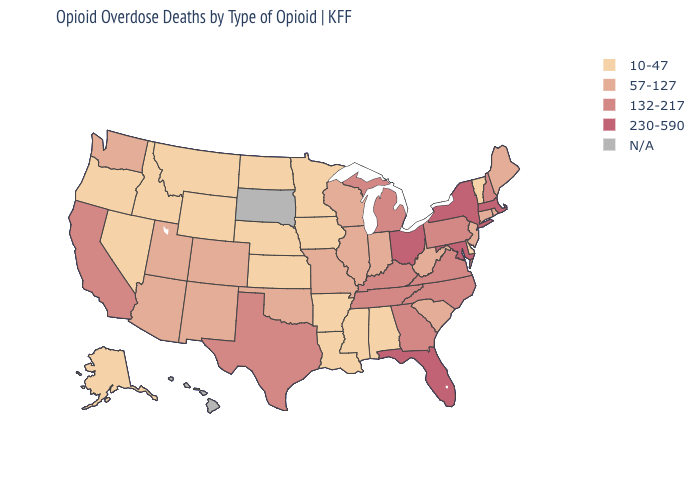Is the legend a continuous bar?
Quick response, please. No. Does Iowa have the lowest value in the USA?
Write a very short answer. Yes. What is the lowest value in the USA?
Give a very brief answer. 10-47. What is the value of Maryland?
Be succinct. 230-590. Name the states that have a value in the range 57-127?
Quick response, please. Arizona, Colorado, Connecticut, Illinois, Indiana, Maine, Missouri, New Jersey, New Mexico, Oklahoma, Rhode Island, South Carolina, Utah, Washington, West Virginia, Wisconsin. What is the value of New Jersey?
Answer briefly. 57-127. What is the value of Oregon?
Keep it brief. 10-47. What is the value of Virginia?
Write a very short answer. 132-217. Which states have the lowest value in the Northeast?
Answer briefly. Vermont. Name the states that have a value in the range 57-127?
Keep it brief. Arizona, Colorado, Connecticut, Illinois, Indiana, Maine, Missouri, New Jersey, New Mexico, Oklahoma, Rhode Island, South Carolina, Utah, Washington, West Virginia, Wisconsin. Is the legend a continuous bar?
Be succinct. No. Does Montana have the lowest value in the West?
Keep it brief. Yes. Is the legend a continuous bar?
Short answer required. No. 